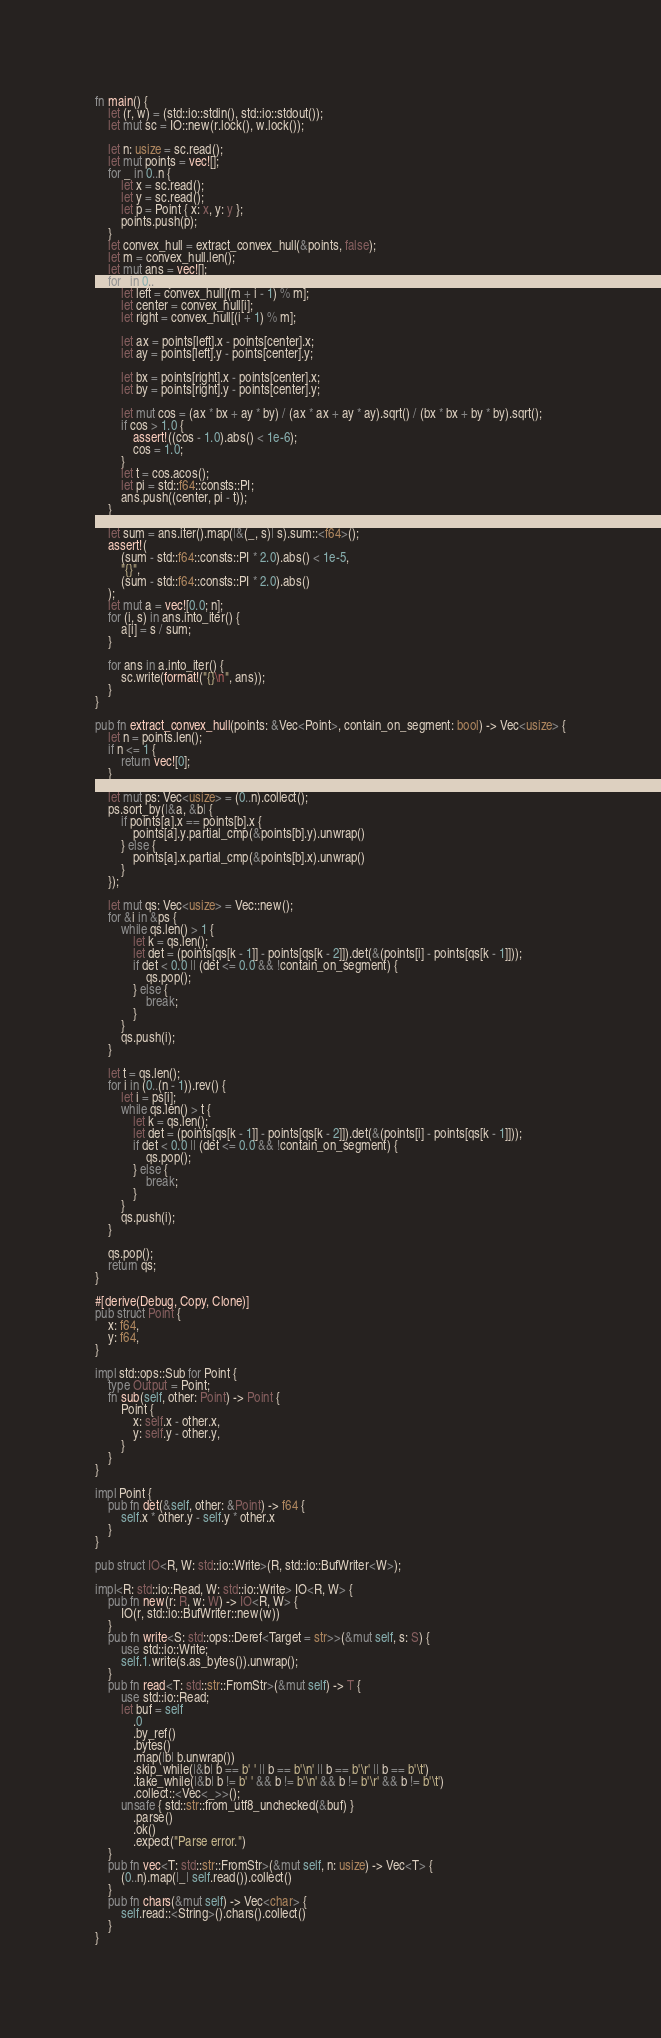Convert code to text. <code><loc_0><loc_0><loc_500><loc_500><_Rust_>fn main() {
    let (r, w) = (std::io::stdin(), std::io::stdout());
    let mut sc = IO::new(r.lock(), w.lock());

    let n: usize = sc.read();
    let mut points = vec![];
    for _ in 0..n {
        let x = sc.read();
        let y = sc.read();
        let p = Point { x: x, y: y };
        points.push(p);
    }
    let convex_hull = extract_convex_hull(&points, false);
    let m = convex_hull.len();
    let mut ans = vec![];
    for i in 0..m {
        let left = convex_hull[(m + i - 1) % m];
        let center = convex_hull[i];
        let right = convex_hull[(i + 1) % m];

        let ax = points[left].x - points[center].x;
        let ay = points[left].y - points[center].y;

        let bx = points[right].x - points[center].x;
        let by = points[right].y - points[center].y;

        let mut cos = (ax * bx + ay * by) / (ax * ax + ay * ay).sqrt() / (bx * bx + by * by).sqrt();
        if cos > 1.0 {
            assert!((cos - 1.0).abs() < 1e-6);
            cos = 1.0;
        }
        let t = cos.acos();
        let pi = std::f64::consts::PI;
        ans.push((center, pi - t));
    }

    let sum = ans.iter().map(|&(_, s)| s).sum::<f64>();
    assert!(
        (sum - std::f64::consts::PI * 2.0).abs() < 1e-5,
        "{}",
        (sum - std::f64::consts::PI * 2.0).abs()
    );
    let mut a = vec![0.0; n];
    for (i, s) in ans.into_iter() {
        a[i] = s / sum;
    }

    for ans in a.into_iter() {
        sc.write(format!("{}\n", ans));
    }
}

pub fn extract_convex_hull(points: &Vec<Point>, contain_on_segment: bool) -> Vec<usize> {
    let n = points.len();
    if n <= 1 {
        return vec![0];
    }

    let mut ps: Vec<usize> = (0..n).collect();
    ps.sort_by(|&a, &b| {
        if points[a].x == points[b].x {
            points[a].y.partial_cmp(&points[b].y).unwrap()
        } else {
            points[a].x.partial_cmp(&points[b].x).unwrap()
        }
    });

    let mut qs: Vec<usize> = Vec::new();
    for &i in &ps {
        while qs.len() > 1 {
            let k = qs.len();
            let det = (points[qs[k - 1]] - points[qs[k - 2]]).det(&(points[i] - points[qs[k - 1]]));
            if det < 0.0 || (det <= 0.0 && !contain_on_segment) {
                qs.pop();
            } else {
                break;
            }
        }
        qs.push(i);
    }

    let t = qs.len();
    for i in (0..(n - 1)).rev() {
        let i = ps[i];
        while qs.len() > t {
            let k = qs.len();
            let det = (points[qs[k - 1]] - points[qs[k - 2]]).det(&(points[i] - points[qs[k - 1]]));
            if det < 0.0 || (det <= 0.0 && !contain_on_segment) {
                qs.pop();
            } else {
                break;
            }
        }
        qs.push(i);
    }

    qs.pop();
    return qs;
}

#[derive(Debug, Copy, Clone)]
pub struct Point {
    x: f64,
    y: f64,
}

impl std::ops::Sub for Point {
    type Output = Point;
    fn sub(self, other: Point) -> Point {
        Point {
            x: self.x - other.x,
            y: self.y - other.y,
        }
    }
}

impl Point {
    pub fn det(&self, other: &Point) -> f64 {
        self.x * other.y - self.y * other.x
    }
}

pub struct IO<R, W: std::io::Write>(R, std::io::BufWriter<W>);

impl<R: std::io::Read, W: std::io::Write> IO<R, W> {
    pub fn new(r: R, w: W) -> IO<R, W> {
        IO(r, std::io::BufWriter::new(w))
    }
    pub fn write<S: std::ops::Deref<Target = str>>(&mut self, s: S) {
        use std::io::Write;
        self.1.write(s.as_bytes()).unwrap();
    }
    pub fn read<T: std::str::FromStr>(&mut self) -> T {
        use std::io::Read;
        let buf = self
            .0
            .by_ref()
            .bytes()
            .map(|b| b.unwrap())
            .skip_while(|&b| b == b' ' || b == b'\n' || b == b'\r' || b == b'\t')
            .take_while(|&b| b != b' ' && b != b'\n' && b != b'\r' && b != b'\t')
            .collect::<Vec<_>>();
        unsafe { std::str::from_utf8_unchecked(&buf) }
            .parse()
            .ok()
            .expect("Parse error.")
    }
    pub fn vec<T: std::str::FromStr>(&mut self, n: usize) -> Vec<T> {
        (0..n).map(|_| self.read()).collect()
    }
    pub fn chars(&mut self) -> Vec<char> {
        self.read::<String>().chars().collect()
    }
}
</code> 